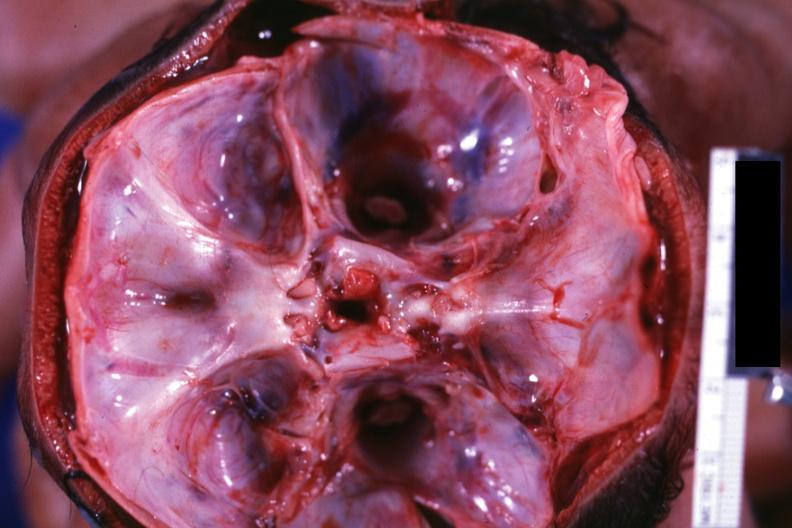what does this image show?
Answer the question using a single word or phrase. Opened skull showing base with two foramina magna 